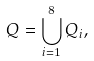Convert formula to latex. <formula><loc_0><loc_0><loc_500><loc_500>Q = \bigcup _ { i = 1 } ^ { 8 } Q _ { i } ,</formula> 